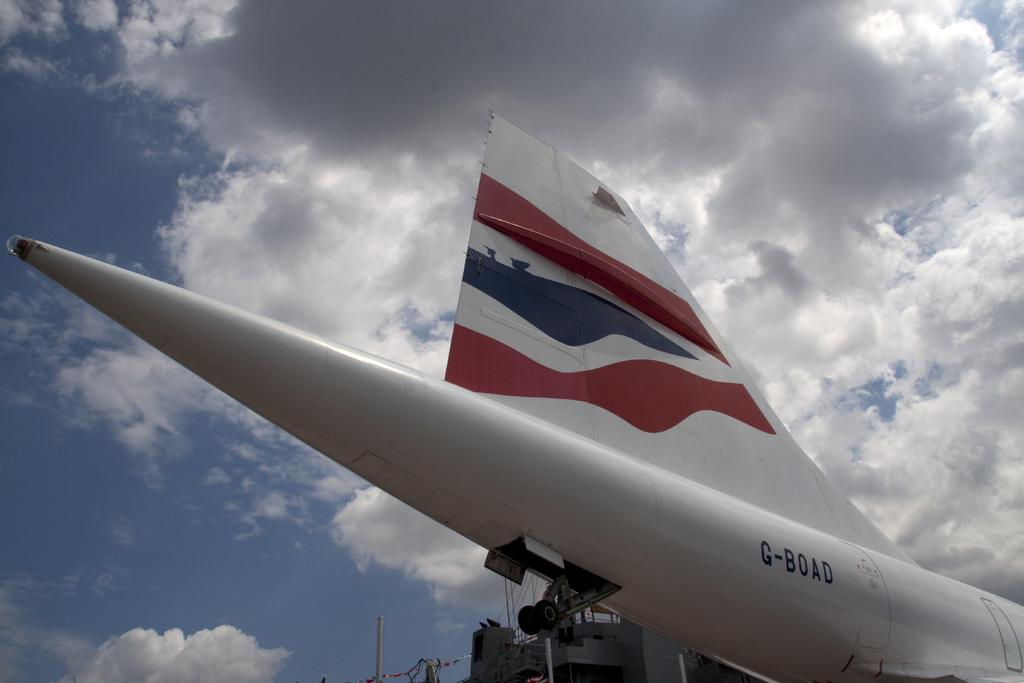What is the main subject of the picture? The main subject of the picture is a plane. What feature of the plane can be observed? The plane has tires. What else can be seen in the image besides the plane? There are buildings and flags visible in the image. What is visible in the background of the image? The sky is visible in the background, and there are clouds present. Where is the playground located in the image? There is no playground present in the image. What type of bottle can be seen in the hands of the person on the plane? There is no person or bottle visible in the image. 